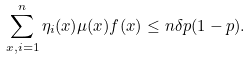<formula> <loc_0><loc_0><loc_500><loc_500>\sum _ { x , i = 1 } ^ { n } \eta _ { i } ( x ) \mu ( x ) f ( x ) \leq n \delta p ( 1 - p ) .</formula> 